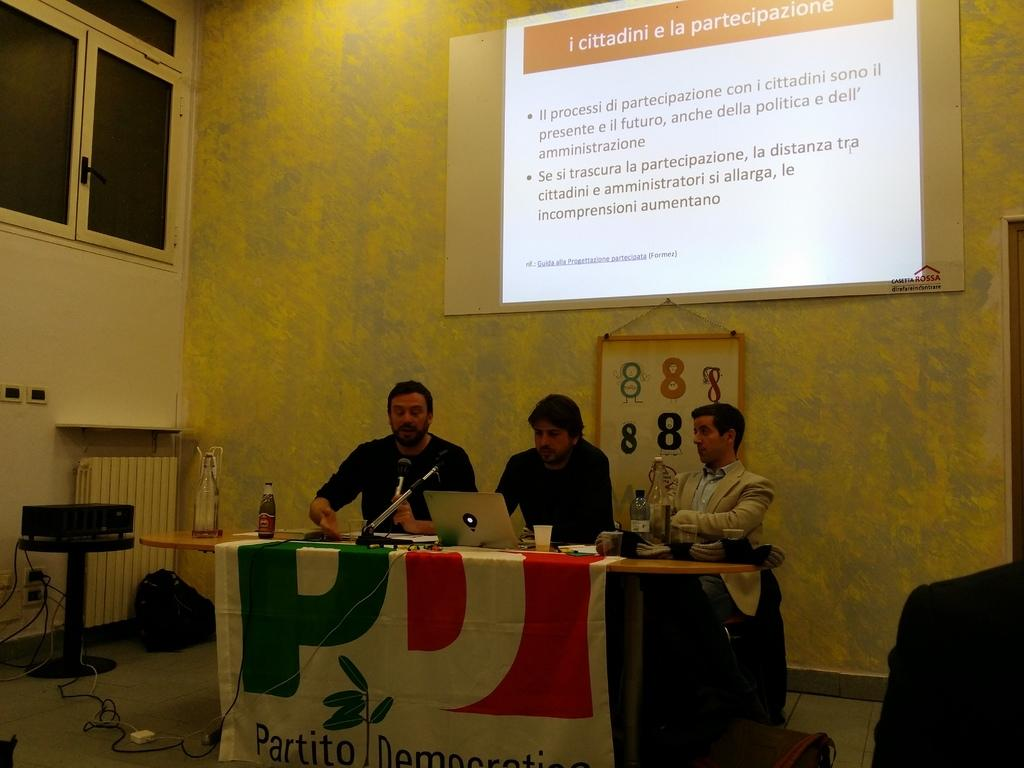How many men are in the image? There are three men in the image. What is the location of the men in the image? The men are in front of a table. What objects can be seen on the table? There are bottles, a laptop, and a cup on the table. What can be seen in the background of the image? There is a wall, a screen, and a window in the background of the image. What type of hospital activity is taking place in the image? There is no hospital or any hospital-related activity present in the image. 